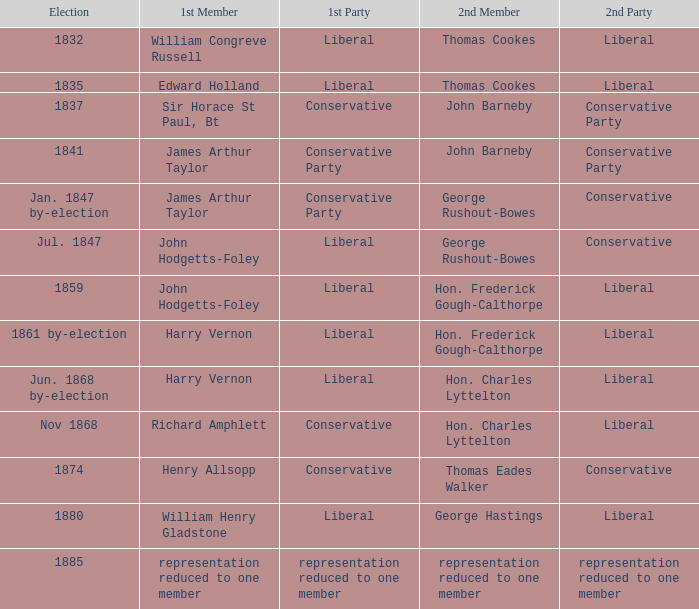Who was the foremost member when the original party experienced a reduction in representation to just one member? Representation reduced to one member. 